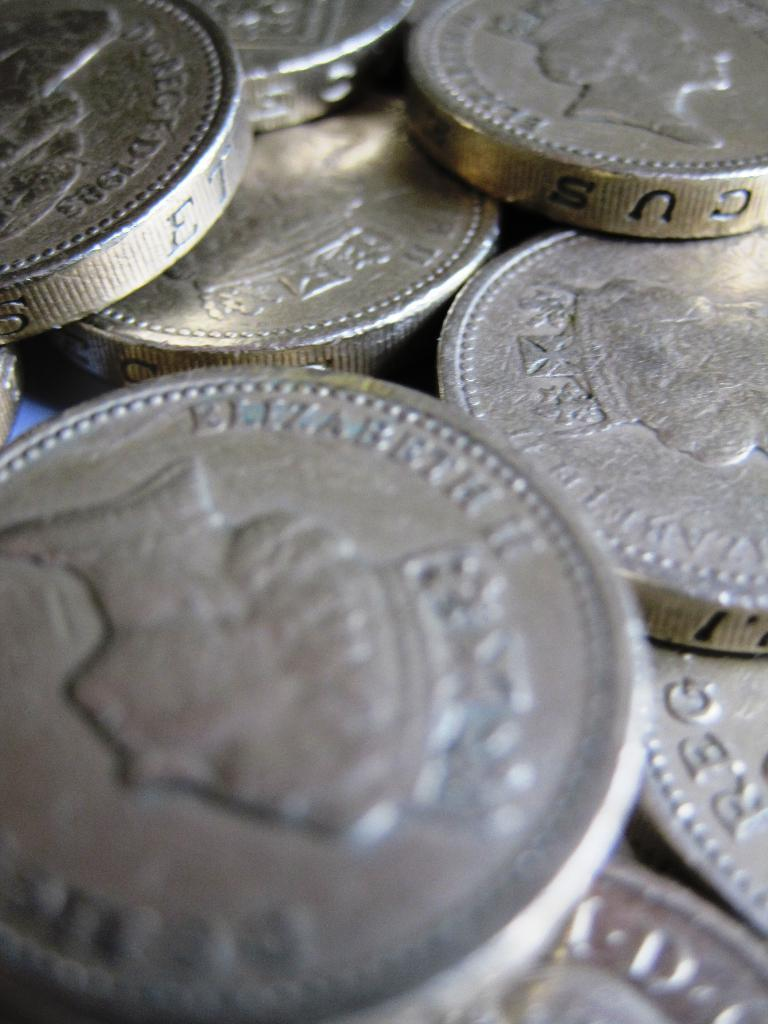Provide a one-sentence caption for the provided image. a bunch of silver coins with Elizabeth II wrote on them. 